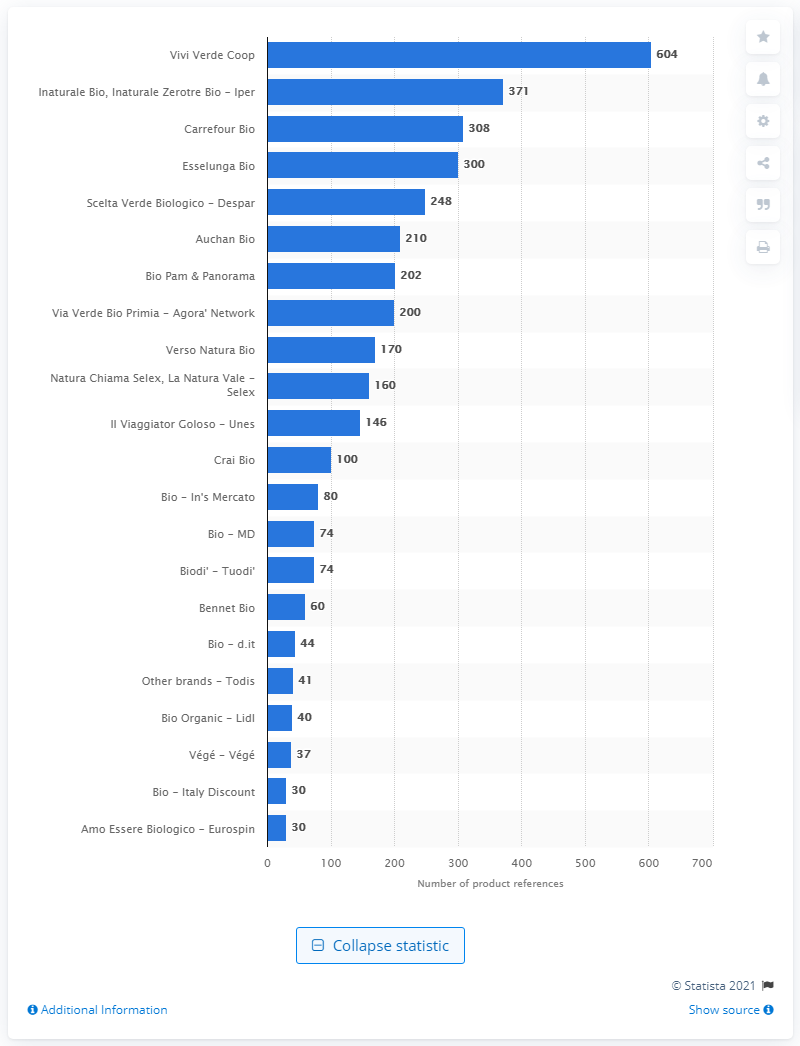Highlight a few significant elements in this photo. Coop had 604 items of the Vivi Verde brand in their inventory. Esselunga had 300 product references. 